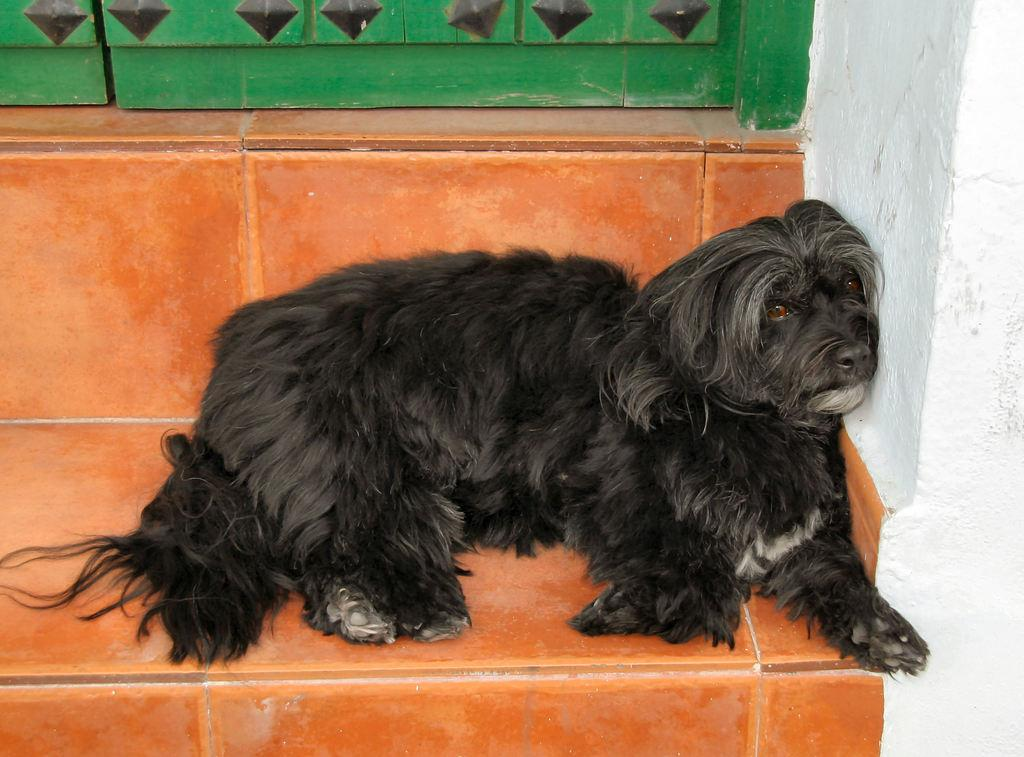What animal can be seen in the image? There is a dog in the image. Where is the dog located in the image? The dog is on a step. What is on the right side of the image? There is a wall on the right side of the image. What part of a structure is visible at the top of the image? Part of a door is visible at the top of the image. What type of bike is the mother riding in the image? There is no mother or bike present in the image; it features a dog on a step with a wall and a door visible. 